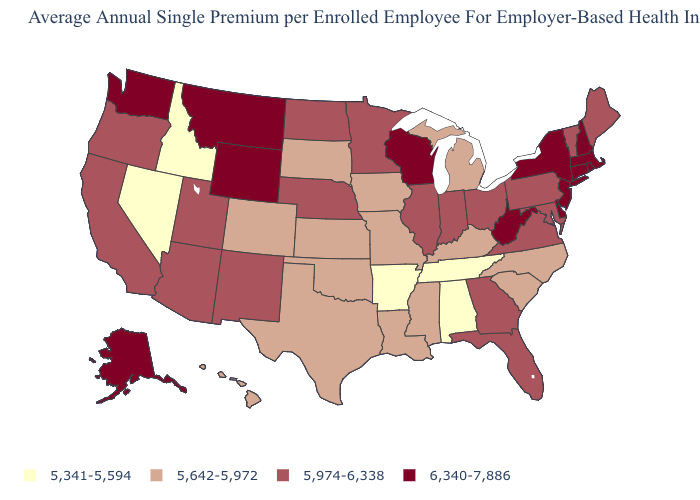Does Kansas have the same value as Arkansas?
Short answer required. No. Name the states that have a value in the range 5,642-5,972?
Short answer required. Colorado, Hawaii, Iowa, Kansas, Kentucky, Louisiana, Michigan, Mississippi, Missouri, North Carolina, Oklahoma, South Carolina, South Dakota, Texas. What is the value of Pennsylvania?
Give a very brief answer. 5,974-6,338. Does Idaho have the lowest value in the West?
Short answer required. Yes. Name the states that have a value in the range 6,340-7,886?
Give a very brief answer. Alaska, Connecticut, Delaware, Massachusetts, Montana, New Hampshire, New Jersey, New York, Rhode Island, Washington, West Virginia, Wisconsin, Wyoming. Name the states that have a value in the range 6,340-7,886?
Be succinct. Alaska, Connecticut, Delaware, Massachusetts, Montana, New Hampshire, New Jersey, New York, Rhode Island, Washington, West Virginia, Wisconsin, Wyoming. What is the highest value in states that border Ohio?
Short answer required. 6,340-7,886. Does the first symbol in the legend represent the smallest category?
Concise answer only. Yes. Among the states that border Louisiana , does Texas have the highest value?
Write a very short answer. Yes. Name the states that have a value in the range 5,642-5,972?
Be succinct. Colorado, Hawaii, Iowa, Kansas, Kentucky, Louisiana, Michigan, Mississippi, Missouri, North Carolina, Oklahoma, South Carolina, South Dakota, Texas. Does the map have missing data?
Keep it brief. No. What is the lowest value in states that border Louisiana?
Write a very short answer. 5,341-5,594. What is the highest value in the MidWest ?
Keep it brief. 6,340-7,886. Name the states that have a value in the range 5,974-6,338?
Give a very brief answer. Arizona, California, Florida, Georgia, Illinois, Indiana, Maine, Maryland, Minnesota, Nebraska, New Mexico, North Dakota, Ohio, Oregon, Pennsylvania, Utah, Vermont, Virginia. 